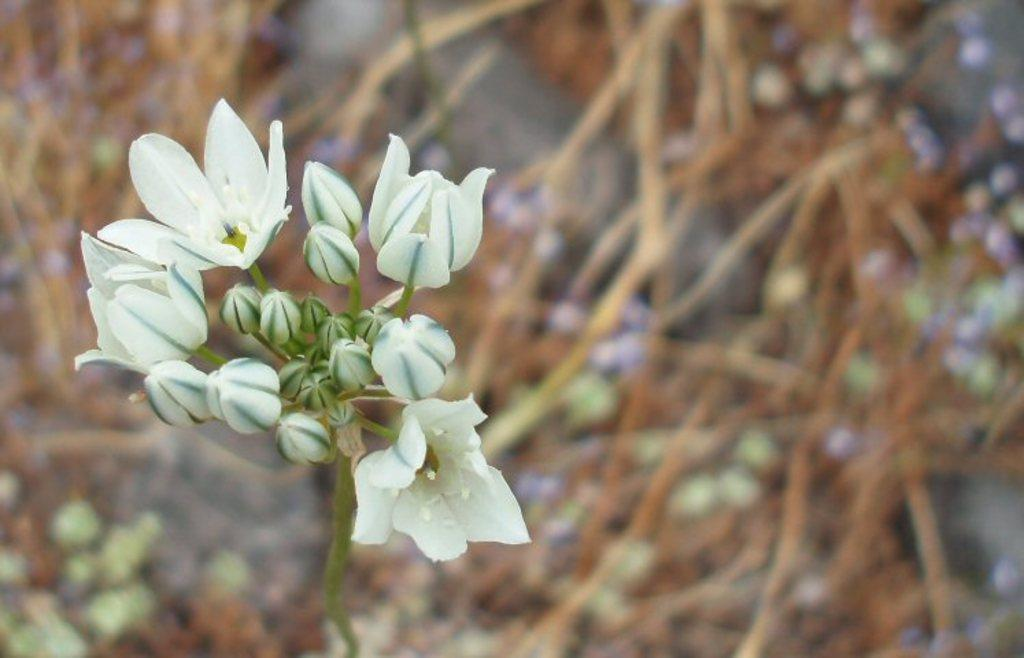What type of living organisms can be seen in the image? There are flowers in the image. What colors are the flowers? The flowers are in white and green colors. What is the color of the background in the image? The background of the image is in brown color. How is the background of the image depicted? The background is blurred. What type of book is the person reading in the image? There is no person or book present in the image; it features flowers and a blurred brown background. Can you describe the wave pattern in the image? There is no wave pattern present in the image; it features flowers and a blurred brown background. 